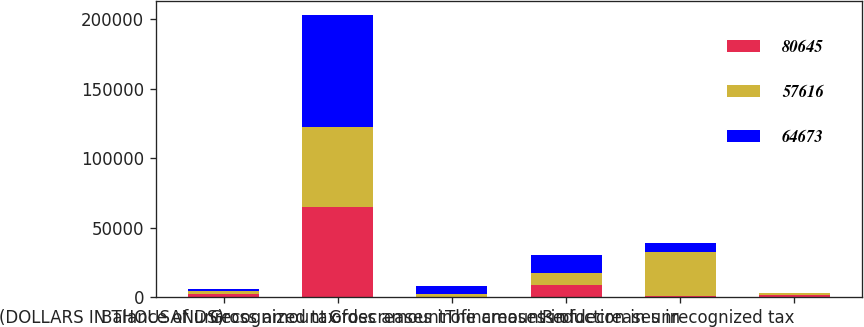<chart> <loc_0><loc_0><loc_500><loc_500><stacked_bar_chart><ecel><fcel>(DOLLARS IN THOUSANDS)<fcel>Balance of unrecognized tax<fcel>Gross amount ofdecreases in<fcel>Gross amount ofincreases in<fcel>The amounts ofdecreases in<fcel>Reduction in unrecognized tax<nl><fcel>80645<fcel>2009<fcel>64673<fcel>26<fcel>8827<fcel>509<fcel>1235<nl><fcel>57616<fcel>2008<fcel>57616<fcel>2200<fcel>8394<fcel>31877<fcel>1611<nl><fcel>64673<fcel>2007<fcel>80645<fcel>5756<fcel>13117<fcel>6549<fcel>76<nl></chart> 